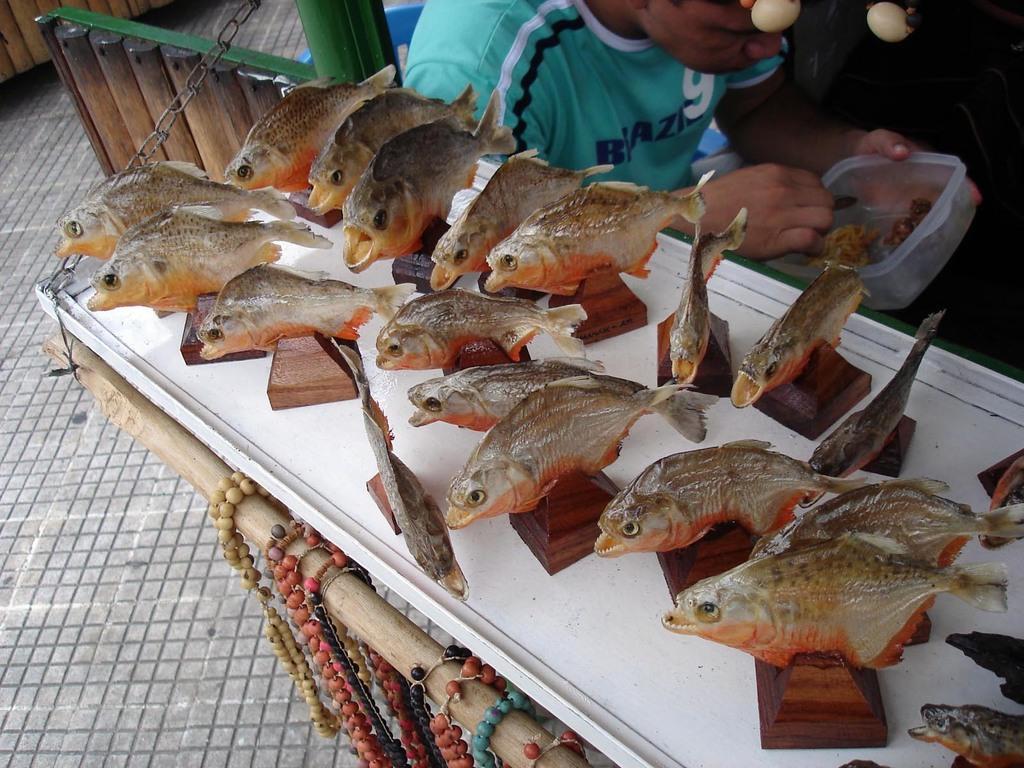Please provide a concise description of this image. In this image we can see a person sitting on a chair holding a spoon and box. In the foreground of the image we can see a group of fishes placed on stands kept on the surface, group of coins placed on a pole. In the background, we can see wood pieces. 